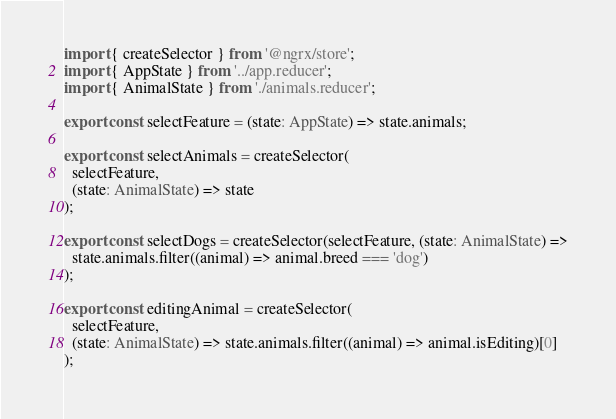Convert code to text. <code><loc_0><loc_0><loc_500><loc_500><_TypeScript_>import { createSelector } from '@ngrx/store';
import { AppState } from '../app.reducer';
import { AnimalState } from './animals.reducer';

export const selectFeature = (state: AppState) => state.animals;

export const selectAnimals = createSelector(
  selectFeature,
  (state: AnimalState) => state
);

export const selectDogs = createSelector(selectFeature, (state: AnimalState) =>
  state.animals.filter((animal) => animal.breed === 'dog')
);

export const editingAnimal = createSelector(
  selectFeature,
  (state: AnimalState) => state.animals.filter((animal) => animal.isEditing)[0]
);
</code> 